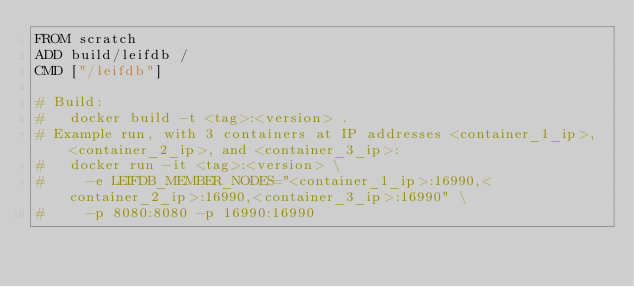Convert code to text. <code><loc_0><loc_0><loc_500><loc_500><_Dockerfile_>FROM scratch
ADD build/leifdb /
CMD ["/leifdb"]

# Build:
#   docker build -t <tag>:<version> .
# Example run, with 3 containers at IP addresses <container_1_ip>, <container_2_ip>, and <container_3_ip>:
#   docker run -it <tag>:<version> \
#     -e LEIFDB_MEMBER_NODES="<container_1_ip>:16990,<container_2_ip>:16990,<container_3_ip>:16990" \
#     -p 8080:8080 -p 16990:16990
</code> 